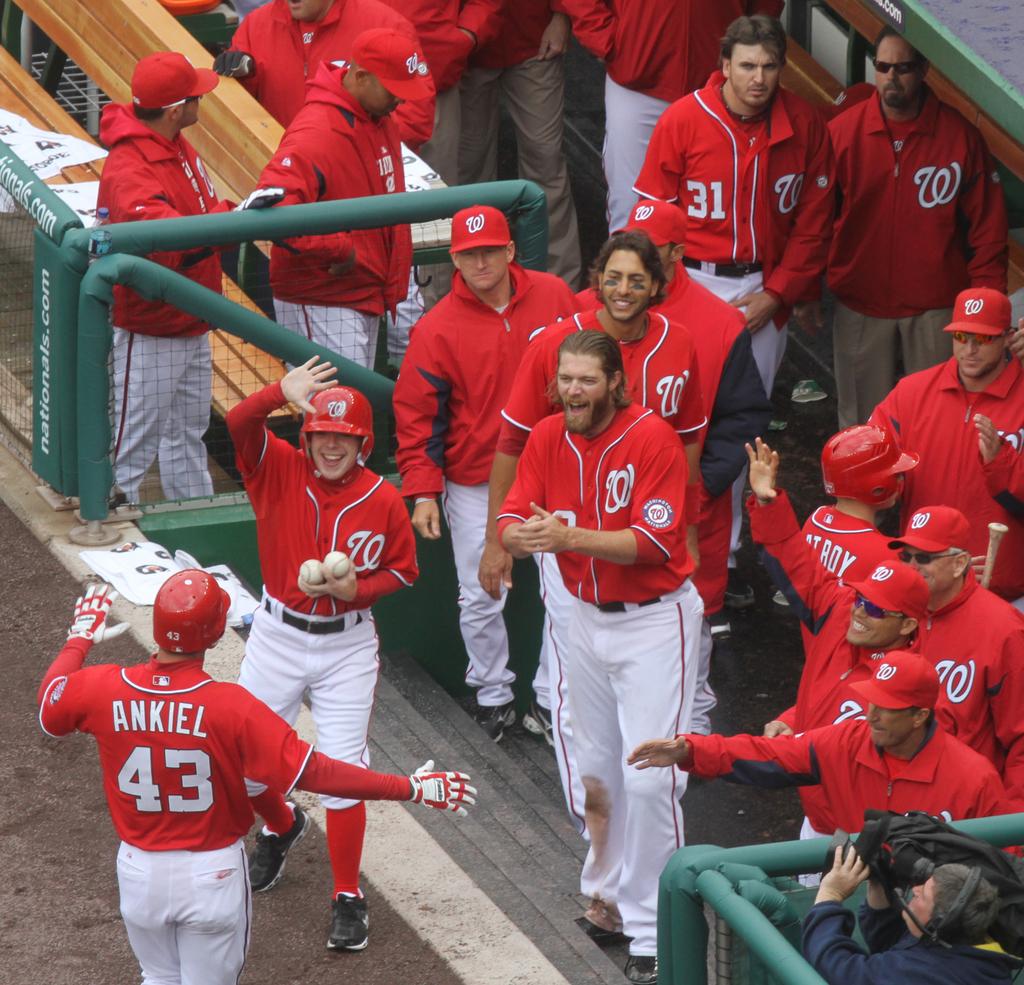What is the name printed on the back of the player in shirt number 43?
Offer a very short reply. Ankiel. Which letter is in cursive on the front of the shirts?
Give a very brief answer. W. 